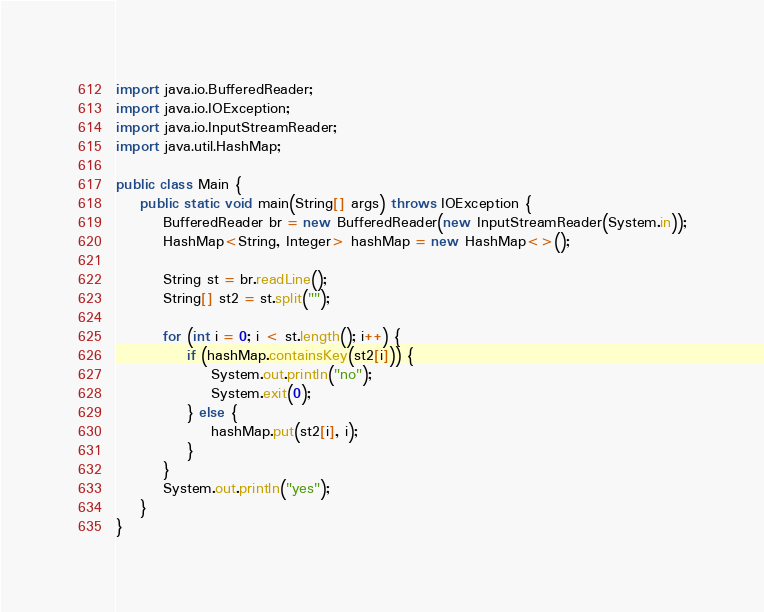<code> <loc_0><loc_0><loc_500><loc_500><_Java_>import java.io.BufferedReader;
import java.io.IOException;
import java.io.InputStreamReader;
import java.util.HashMap;

public class Main {
	public static void main(String[] args) throws IOException {
		BufferedReader br = new BufferedReader(new InputStreamReader(System.in));
		HashMap<String, Integer> hashMap = new HashMap<>();

		String st = br.readLine();
		String[] st2 = st.split("");

		for (int i = 0; i < st.length(); i++) {
			if (hashMap.containsKey(st2[i])) {
				System.out.println("no");
				System.exit(0);
			} else {
				hashMap.put(st2[i], i);
			}
		}
		System.out.println("yes");
	}
}
</code> 